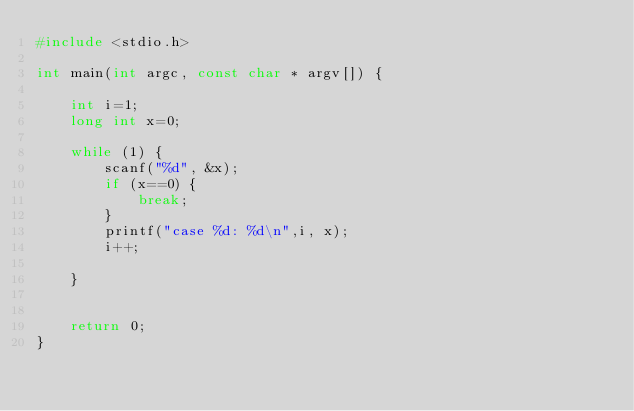Convert code to text. <code><loc_0><loc_0><loc_500><loc_500><_C_>#include <stdio.h>
 
int main(int argc, const char * argv[]) {
 
    int i=1;
    long int x=0;
     
    while (1) {
        scanf("%d", &x);
        if (x==0) {
            break;
        }
        printf("case %d: %d\n",i, x);
        i++;
         
    }
 
     
    return 0;
}</code> 